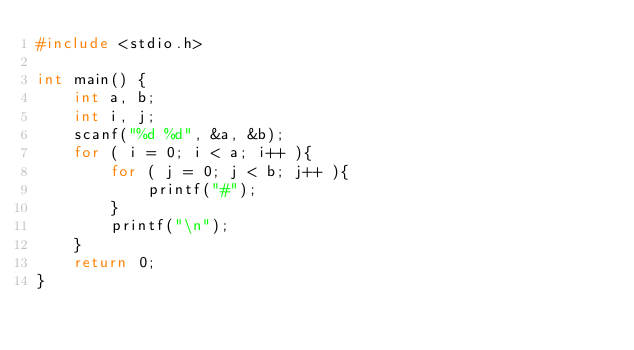Convert code to text. <code><loc_0><loc_0><loc_500><loc_500><_C_>#include <stdio.h>

int main() {
    int a, b;
    int i, j;
    scanf("%d %d", &a, &b);
    for ( i = 0; i < a; i++ ){
        for ( j = 0; j < b; j++ ){
            printf("#");
        }
        printf("\n");
    }
    return 0;
}</code> 